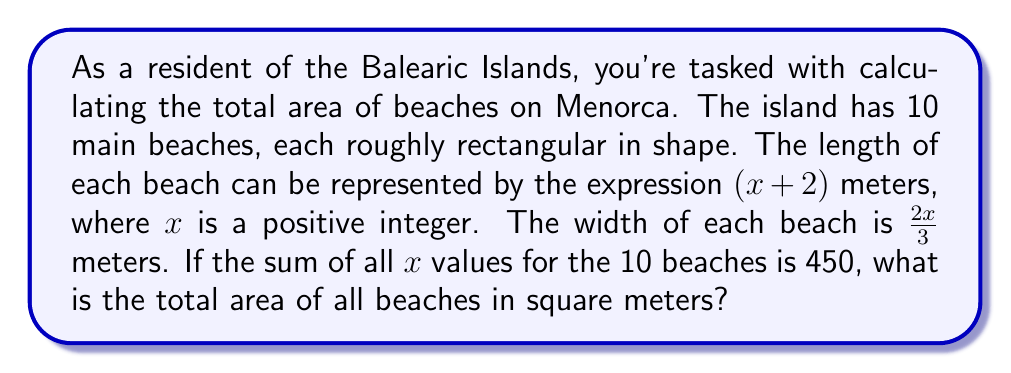Solve this math problem. Let's approach this step-by-step:

1) First, we need to find the area formula for a single beach:
   Area = length × width
   $A = (x + 2) \cdot \frac{2x}{3}$

2) Expanding this:
   $A = \frac{2x^2}{3} + \frac{4x}{3}$

3) We're told that the sum of all $x$ values is 450. Since there are 10 beaches, the average $x$ value is:
   $\bar{x} = \frac{450}{10} = 45$

4) We can use this average $x$ value in our area formula to find the average area of a beach:
   $\bar{A} = \frac{2(45)^2}{3} + \frac{4(45)}{3}$
   $= \frac{2(2025)}{3} + 60$
   $= 1350 + 60 = 1410$ square meters

5) Since there are 10 beaches, we multiply this average area by 10 to get the total area:
   Total Area $= 10 \cdot 1410 = 14100$ square meters
Answer: The total area of all beaches on Menorca is 14100 square meters. 